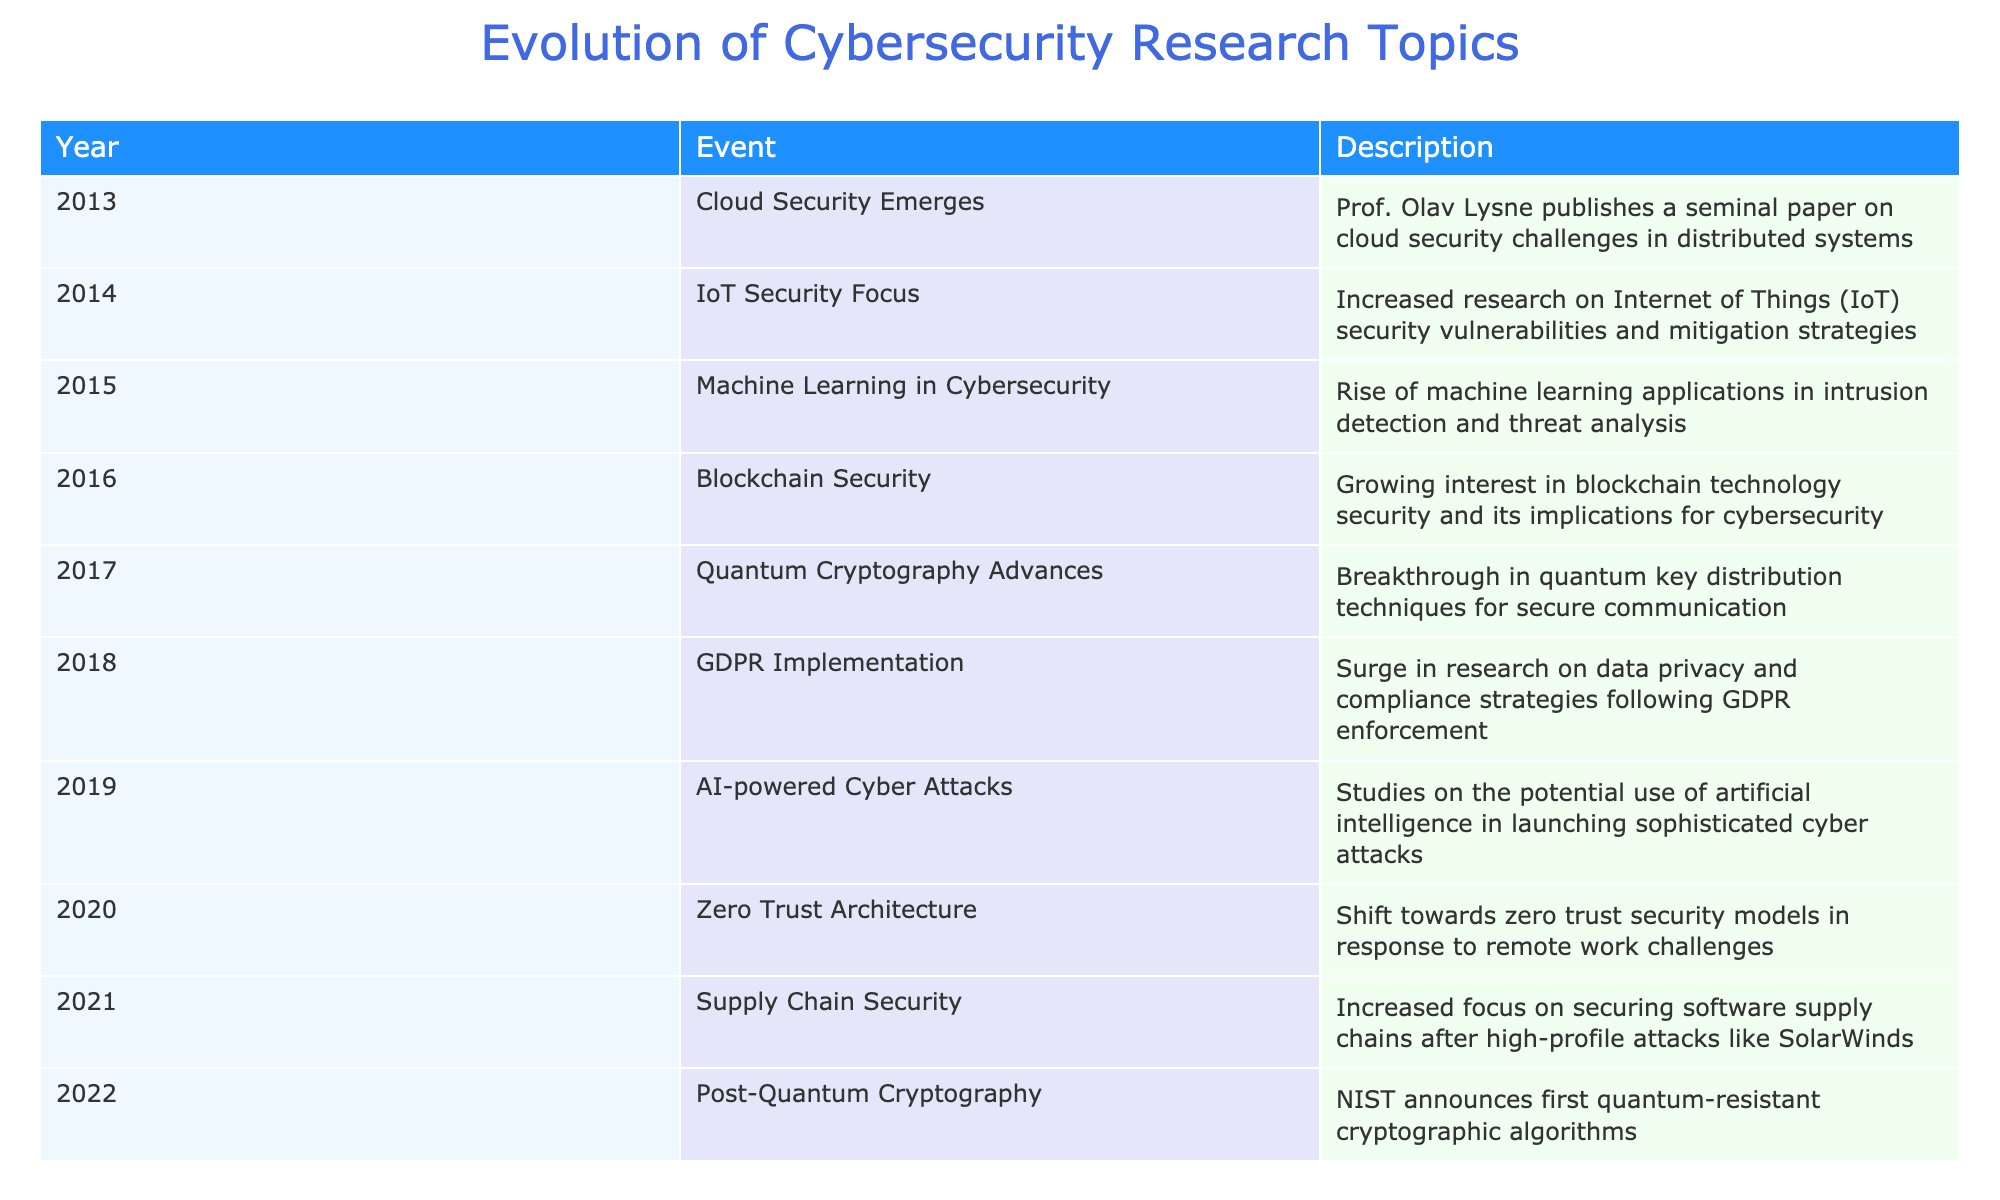What significant cybersecurity event occurred in 2013? The table indicates that in 2013, cloud security emerged as a significant topic with a published paper by Prof. Olav Lysne discussing cloud security challenges.
Answer: Cloud Security Emerges Which year witnessed the implementation of GDPR? According to the table, the implementation of GDPR took place in 2018, leading to an increase in research on data privacy and compliance.
Answer: 2018 How many years after the emergence of cloud security was the focus on IoT security? The emergence of cloud security was in 2013 and the focus on IoT security began in 2014; thus, it was one year after the cloud security emergence.
Answer: 1 year Was there research on AI-powered cyber attacks before 2020? The table shows that research on AI-powered cyber attacks started in 2019, indicating that yes, research on this topic was happening before 2020.
Answer: Yes What topic gained attention in the field of cybersecurity right after GDPR was implemented? Following the implementation of GDPR in 2018, the next significant focus in cybersecurity research was on AI-powered cyber attacks in 2019.
Answer: AI-powered Cyber Attacks Which two areas of cybersecurity research were addressed in 2016 and 2017? The table highlights that blockchain security gained interest in 2016 while quantum cryptography made advances in 2017.
Answer: Blockchain Security and Quantum Cryptography Calculate the total number of distinct cybersecurity events mentioned from 2013 to 2022. By counting each event listed in the table, we find there are 10 distinct cybersecurity events from 2013 to 2022, indicating a diverse range of topics developed over the decade.
Answer: 10 Is it true that the concept of Zero Trust Architecture was introduced before 2020? The table indicates that Zero Trust Architecture was introduced in 2020; thus, it is not true that this concept was presented before that year.
Answer: No 